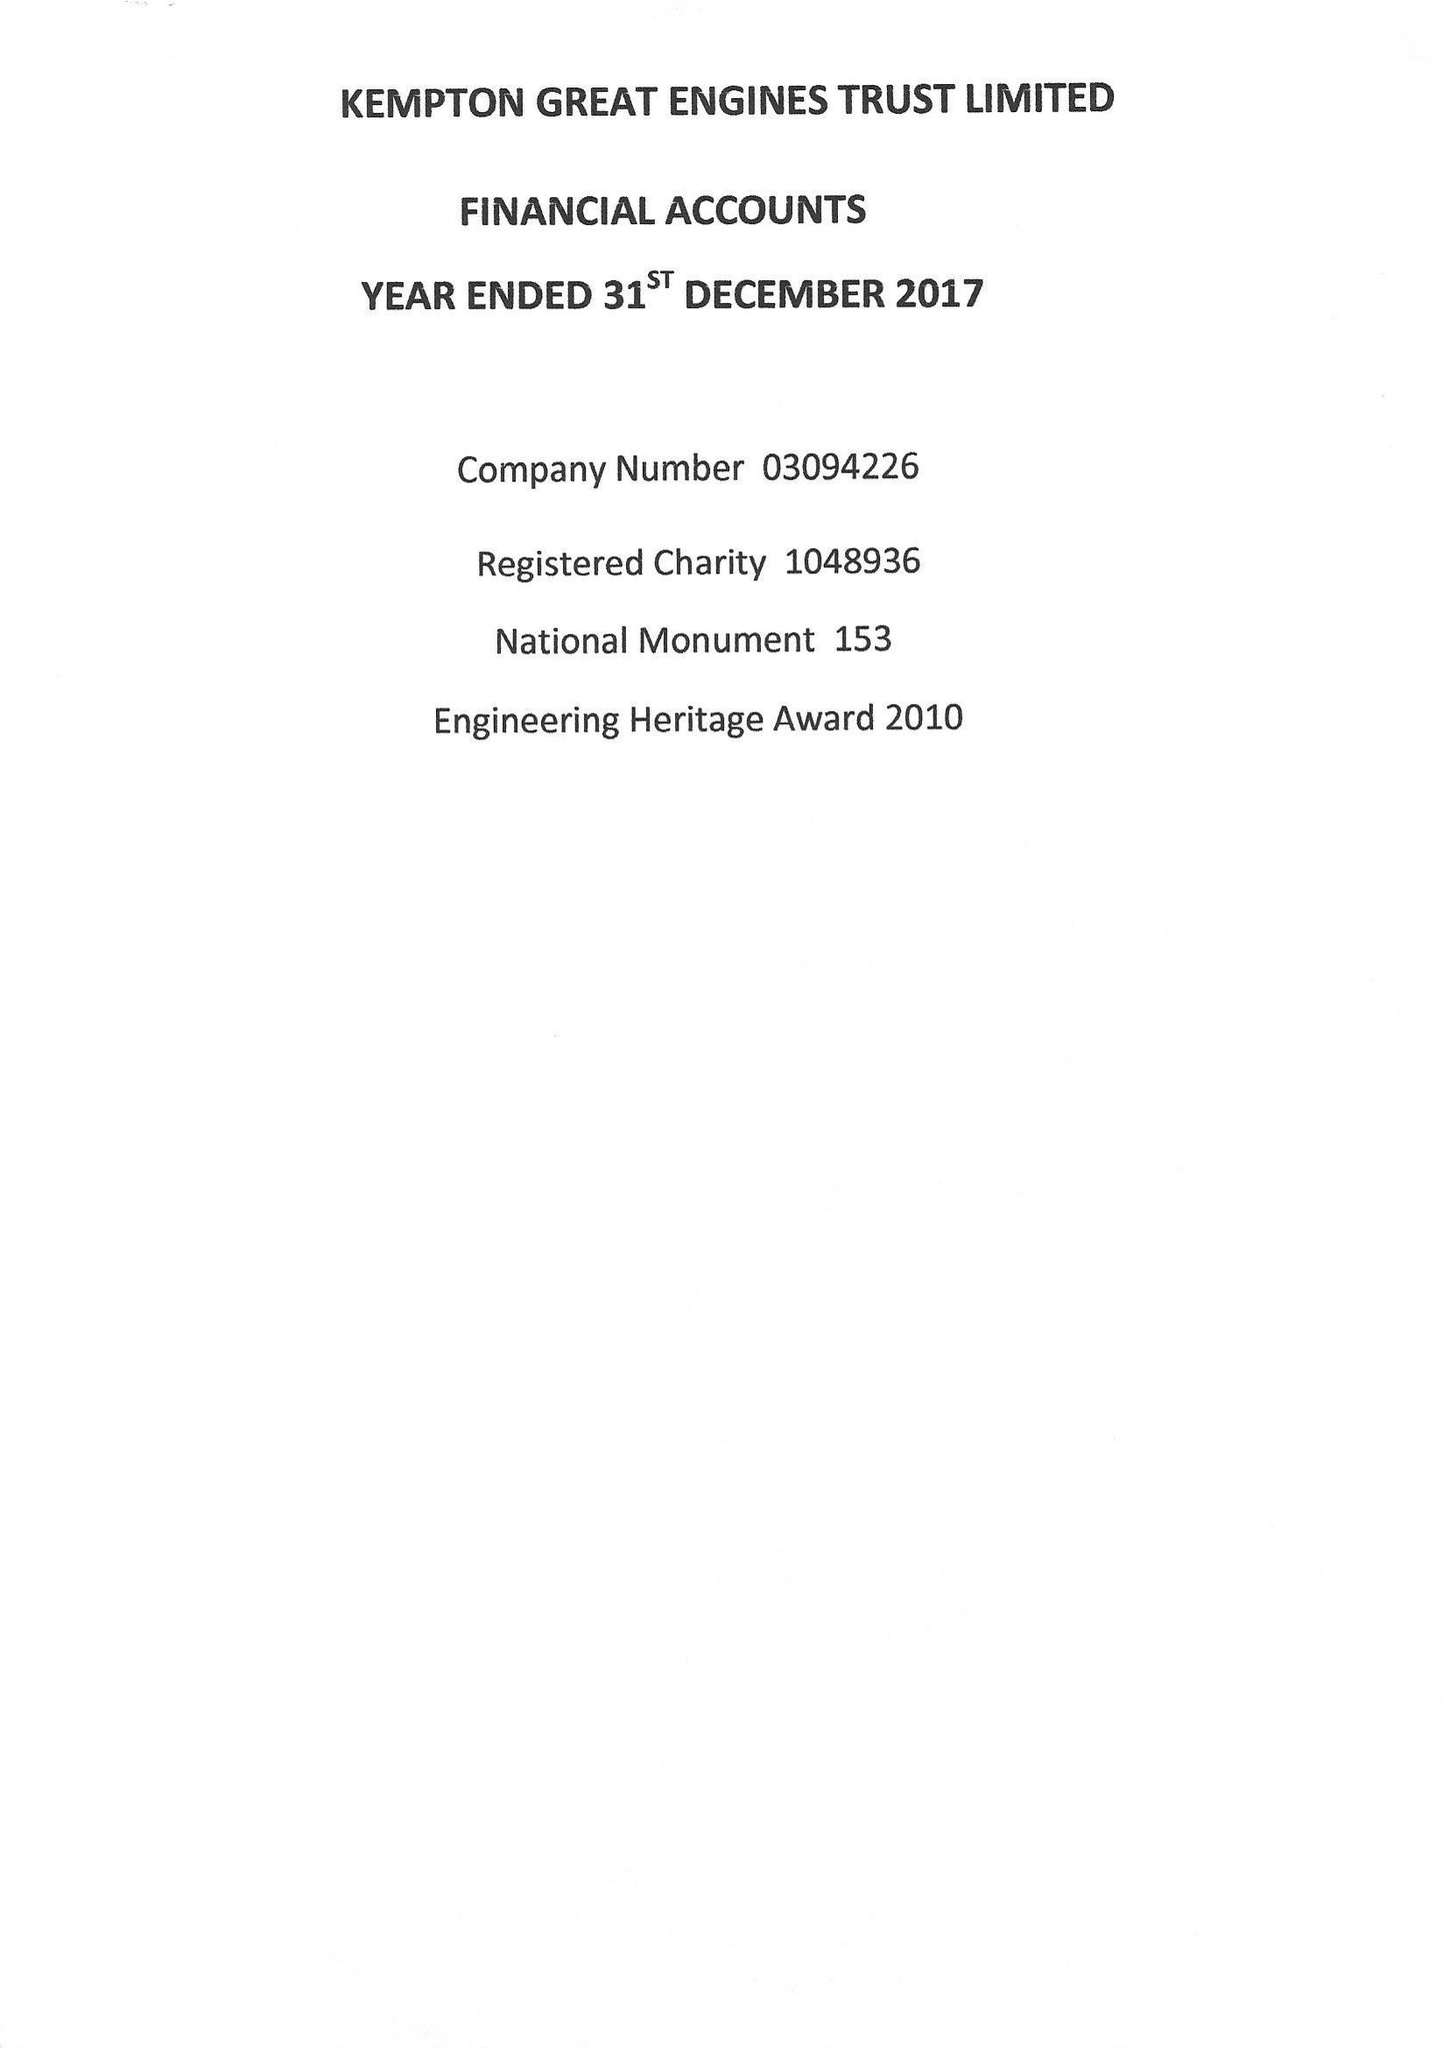What is the value for the spending_annually_in_british_pounds?
Answer the question using a single word or phrase. 71863.00 